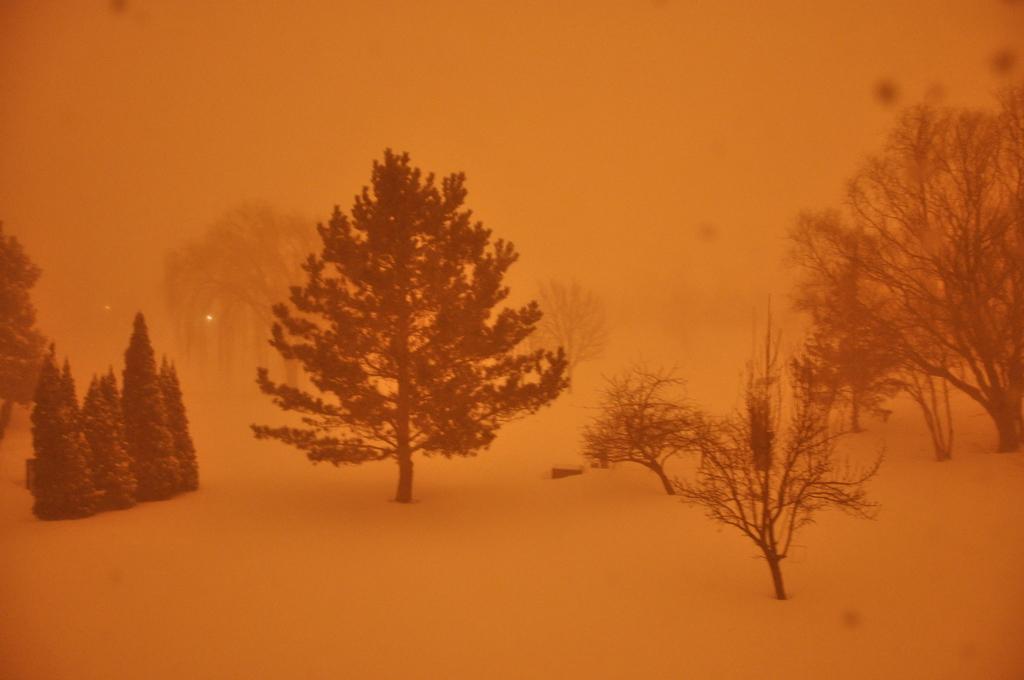Can you describe this image briefly? In this picture we can see trees and in the background we can see the fog. 